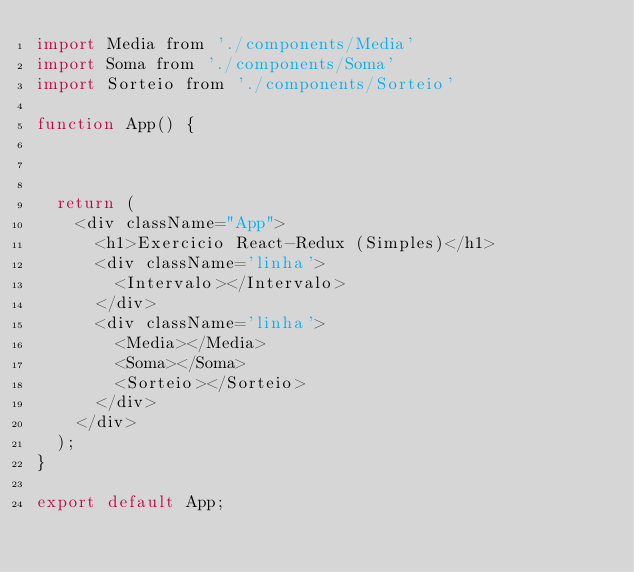<code> <loc_0><loc_0><loc_500><loc_500><_JavaScript_>import Media from './components/Media'
import Soma from './components/Soma'
import Sorteio from './components/Sorteio'

function App() {



  return (
    <div className="App">
      <h1>Exercicio React-Redux (Simples)</h1>
      <div className='linha'> 
        <Intervalo></Intervalo>
      </div>
      <div className='linha'> 
        <Media></Media>
        <Soma></Soma>
        <Sorteio></Sorteio>
      </div>
    </div>
  );
}

export default App;
</code> 